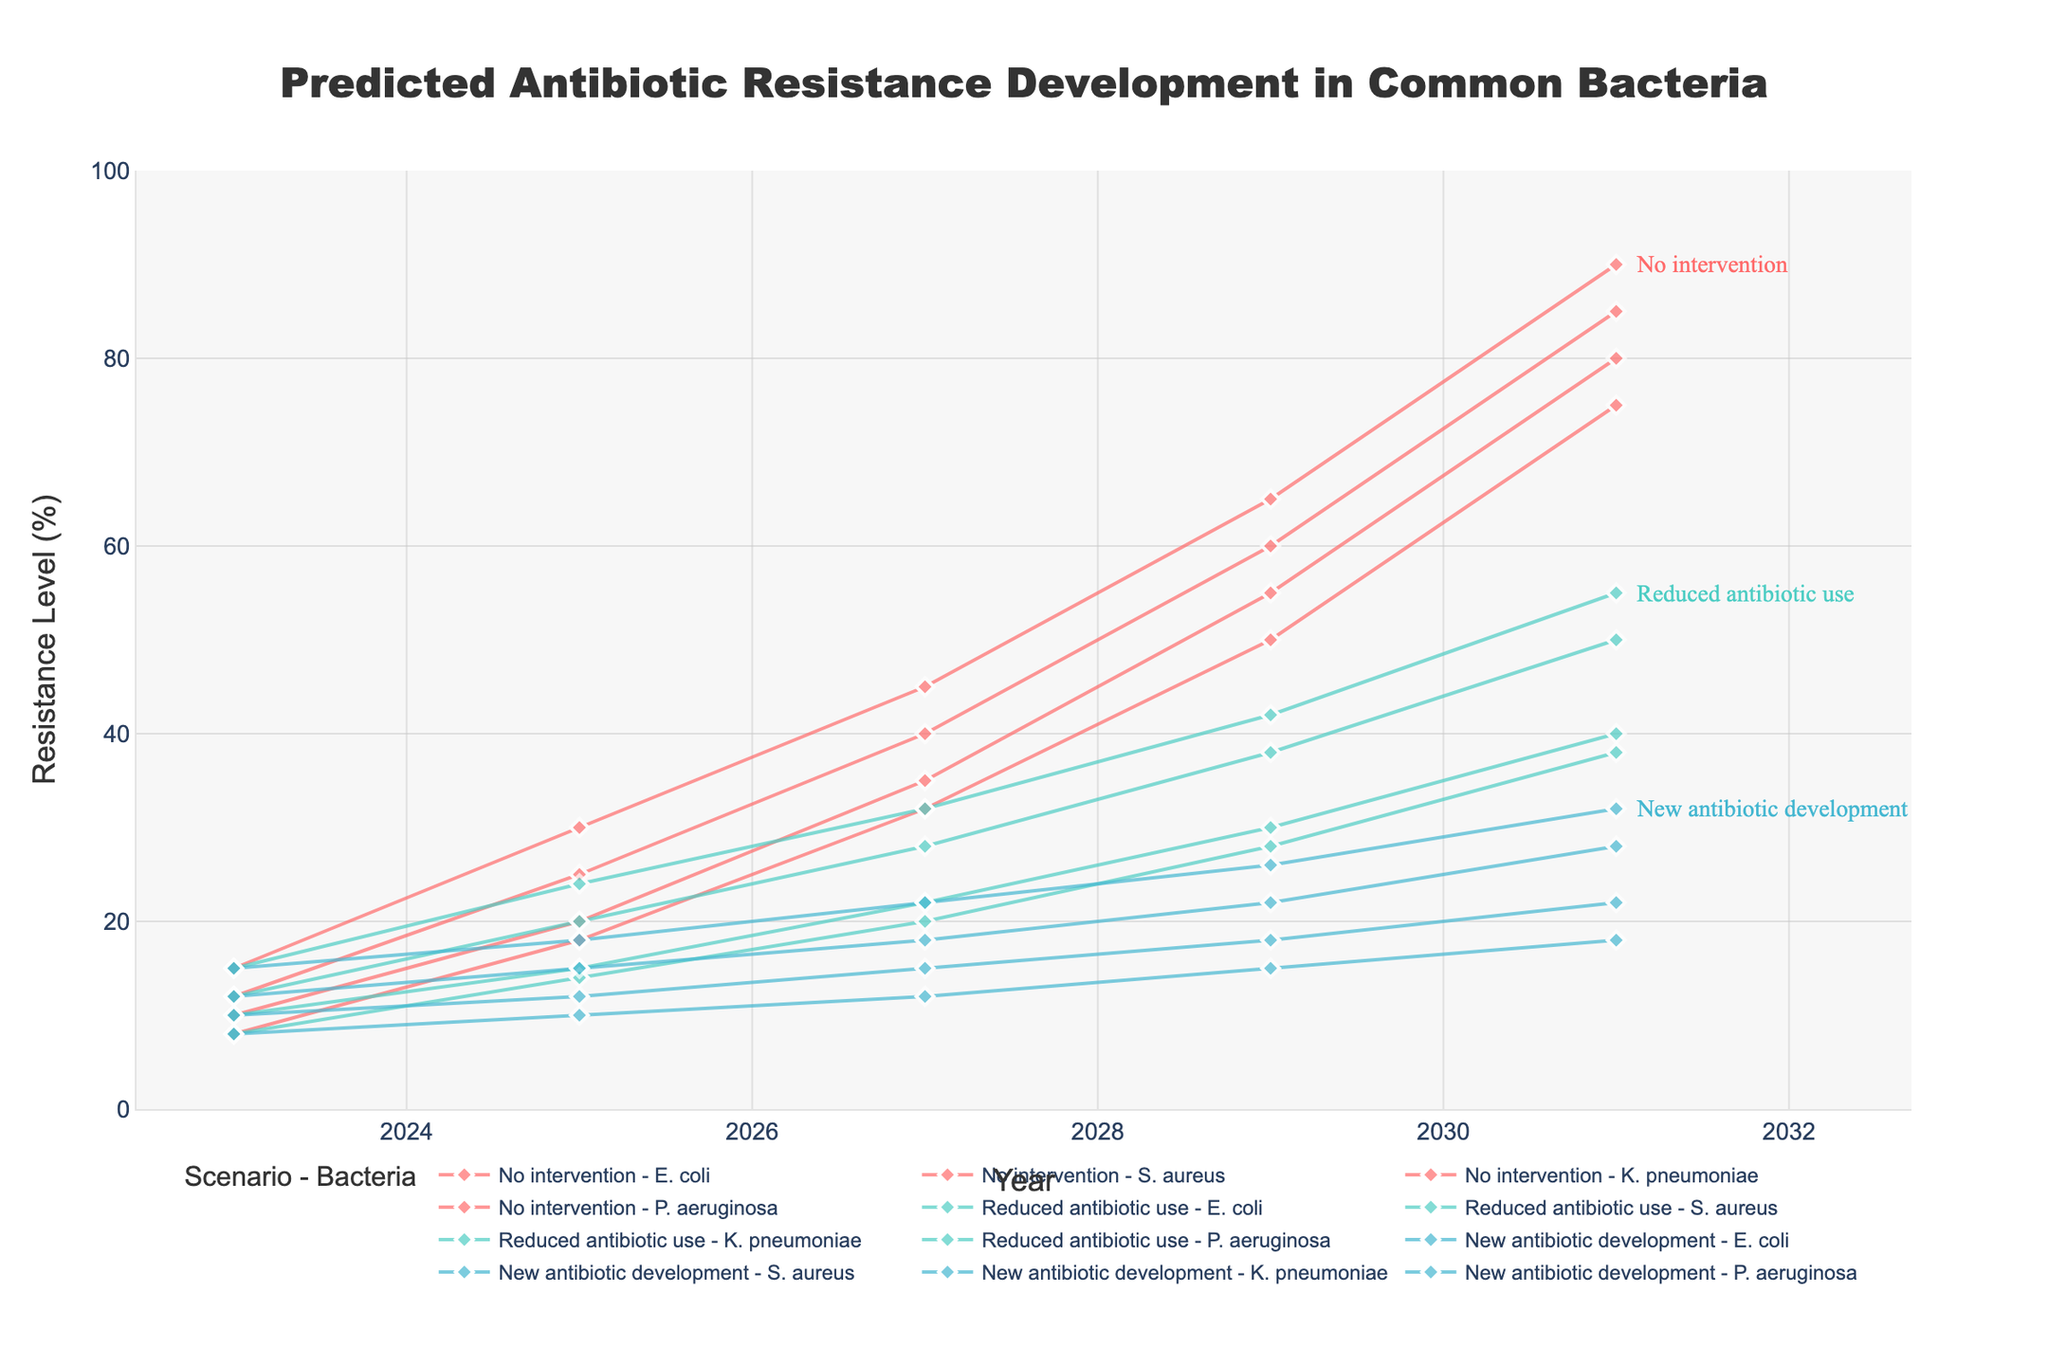What's the title of this figure? The title of the figure is usually located at the top of the chart and provides a brief description of the data being visualized.
Answer: "Predicted Antibiotic Resistance Development in Common Bacteria" What does the y-axis represent? The y-axis typically indicates the variable being measured. In this chart, it shows the level of antibiotic resistance over time.
Answer: Resistance Level (%) How does the antibiotic resistance of E. coli change from 2023 to 2031 in the "No intervention" scenario? To answer this, locate the "No intervention" scenario and track the E. coli line between 2023 and 2031. In 2023, the resistance is at 10%, and by 2031, it reaches 80%.
Answer: Increases from 10% to 80% In 2027, which bacteria show higher resistance: S. aureus under "Reduced antibiotic use" or K. pneumoniae under "New antibiotic development"? Look at the data points for 2027. Specifically compare S. aureus under "Reduced antibiotic use", which is at 20%, with K. pneumoniae under "New antibiotic development", which is at 18%.
Answer: S. aureus under "Reduced antibiotic use" Which scenario shows the least increase in P. aeruginosa resistance from 2023 to 2031? Compare the increase in resistance levels for P. aeruginosa across all scenarios from 2023 to 2031. The smallest increase is found under the "New antibiotic development" scenario, from 15% to 32%.
Answer: New antibiotic development What's the average resistance level of K. pneumoniae across all scenarios in 2025? Find and sum the resistance levels of K. pneumoniae in 2025 for all scenarios (No intervention: 25%, Reduced antibiotic use: 20%, New antibiotic development: 15%) and divide by the number of scenarios. (25 + 20 + 15) / 3 = 20%
Answer: 20% By how much does the resistance level of S. aureus change from 2025 to 2029 under the "Reduced antibiotic use" scenario? Identify the resistance levels of S. aureus in 2025 and 2029 under the "Reduced antibiotic use" scenario. Subtract the 2025 level (14%) from the 2029 level (28%) to find the difference. 28% - 14% = 14%
Answer: 14% Which bacteria shows the highest resistance level in 2031 under the "No intervention" scenario? In 2031, under the "No intervention" scenario, compare the resistance levels for all four bacteria. The highest resistance is observed in P. aeruginosa at 90%.
Answer: P. aeruginosa How do resistance levels of K. pneumoniae compare in 2023 and 2027 under the "New antibiotic development" scenario? Look at the resistance levels of K. pneumoniae in 2023 and 2027 under the "New antibiotic development" scenario. The resistance increases from 12% in 2023 to 18% in 2027.
Answer: Increases from 12% to 18% Which year shows the most significant increase in E. coli resistance for the "No intervention" scenario? Examine the increments of resistance level for E. coli between consecutive years in the "No intervention" scenario. The most significant increase occurs between 2029 (55%) and 2031 (80%), an increase of 25%.
Answer: Between 2029 and 2031 